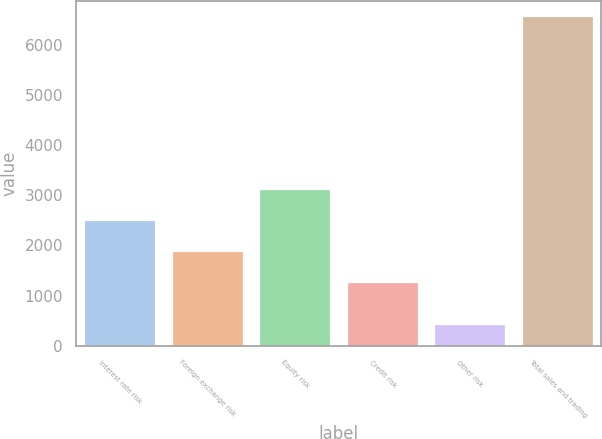Convert chart. <chart><loc_0><loc_0><loc_500><loc_500><bar_chart><fcel>Interest rate risk<fcel>Foreign exchange risk<fcel>Equity risk<fcel>Credit risk<fcel>Other risk<fcel>Total sales and trading<nl><fcel>2486.2<fcel>1872.1<fcel>3100.3<fcel>1258<fcel>409<fcel>6550<nl></chart> 